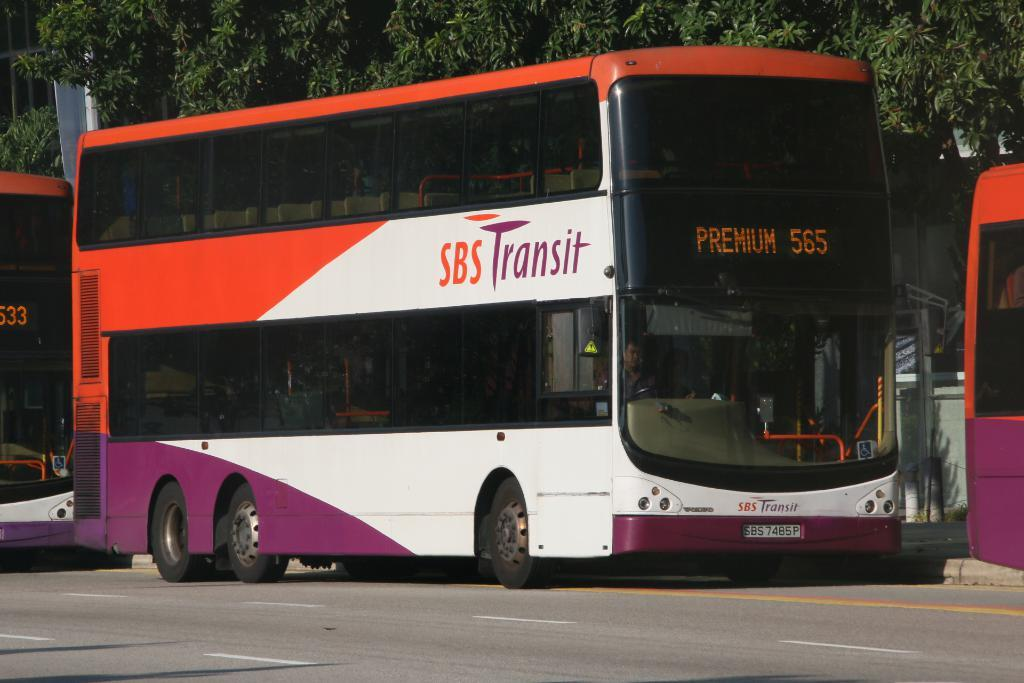What is the main subject in the foreground of the image? There is a bus in the foreground of the image. Where is the bus located? The bus is on the road. What can be seen on either side of the image? There are truncated buses on either side of the image. What type of natural elements are visible in the image? There are trees visible at the top of the image. What type of trail can be seen growing in the image? There is no trail or growth visible in the image; it primarily features a bus and trees. 